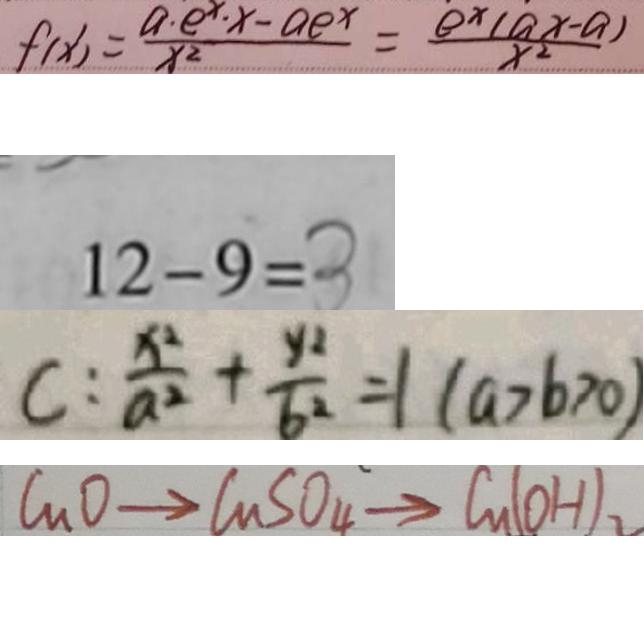<formula> <loc_0><loc_0><loc_500><loc_500>f ( x ) ^ { \prime } = \frac { a \cdot e ^ { x } \cdot x - a e ^ { x } } { x ^ { 2 } } = \frac { e ^ { x } ( a x - a ) } { x ^ { 2 } } 
 1 2 - 9 = 3 
 C : \frac { x ^ { 2 } } { a ^ { 2 } } + \frac { y _ { 2 } } { b ^ { 2 } } = 1 ( a > b > 0 ) 
 C u O \rightarrow C u S O _ { 4 } \rightarrow C u ( O H ) _ { 2 }</formula> 